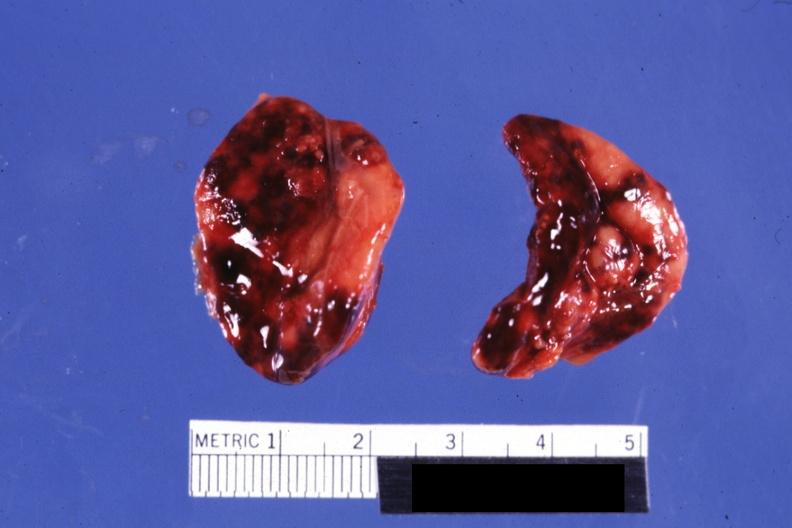do focal hemorrhages not know history looks like placental abruption?
Answer the question using a single word or phrase. Yes 